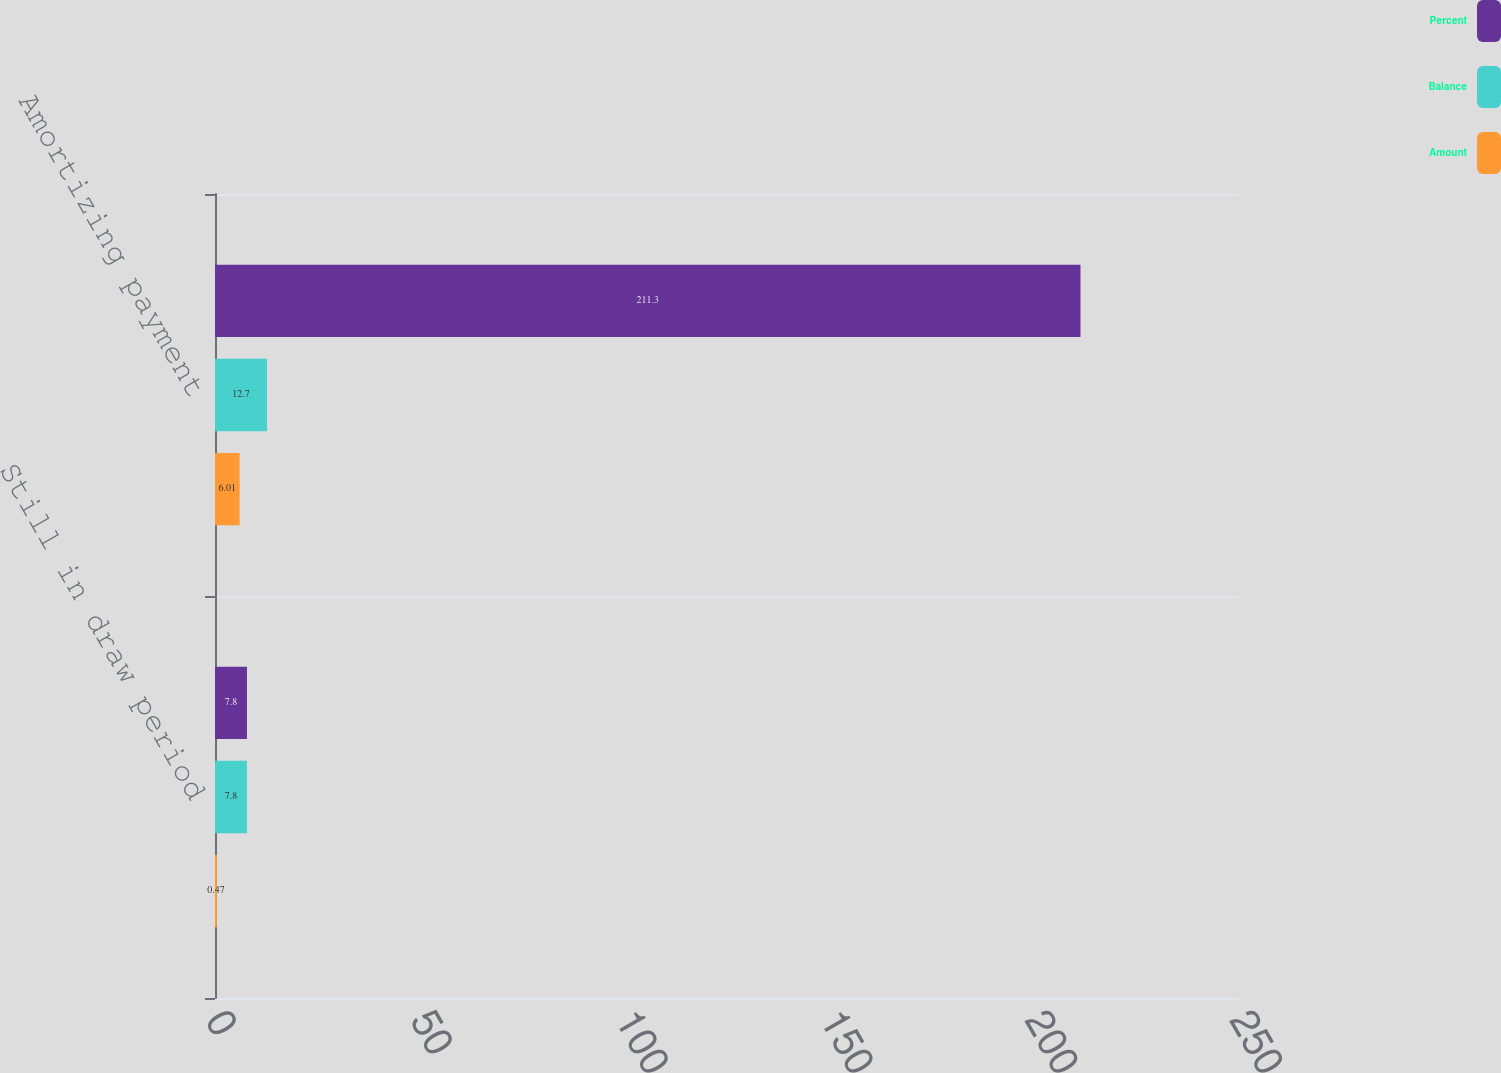<chart> <loc_0><loc_0><loc_500><loc_500><stacked_bar_chart><ecel><fcel>Still in draw period<fcel>Amortizing payment<nl><fcel>Percent<fcel>7.8<fcel>211.3<nl><fcel>Balance<fcel>7.8<fcel>12.7<nl><fcel>Amount<fcel>0.47<fcel>6.01<nl></chart> 